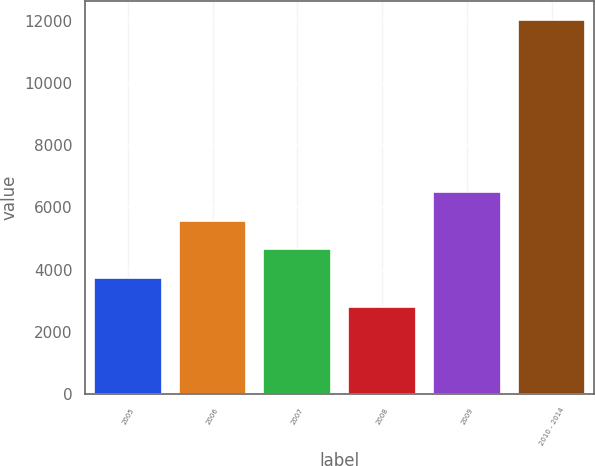<chart> <loc_0><loc_0><loc_500><loc_500><bar_chart><fcel>2005<fcel>2006<fcel>2007<fcel>2008<fcel>2009<fcel>2010 - 2014<nl><fcel>3730.3<fcel>5576.9<fcel>4653.6<fcel>2807<fcel>6500.2<fcel>12040<nl></chart> 